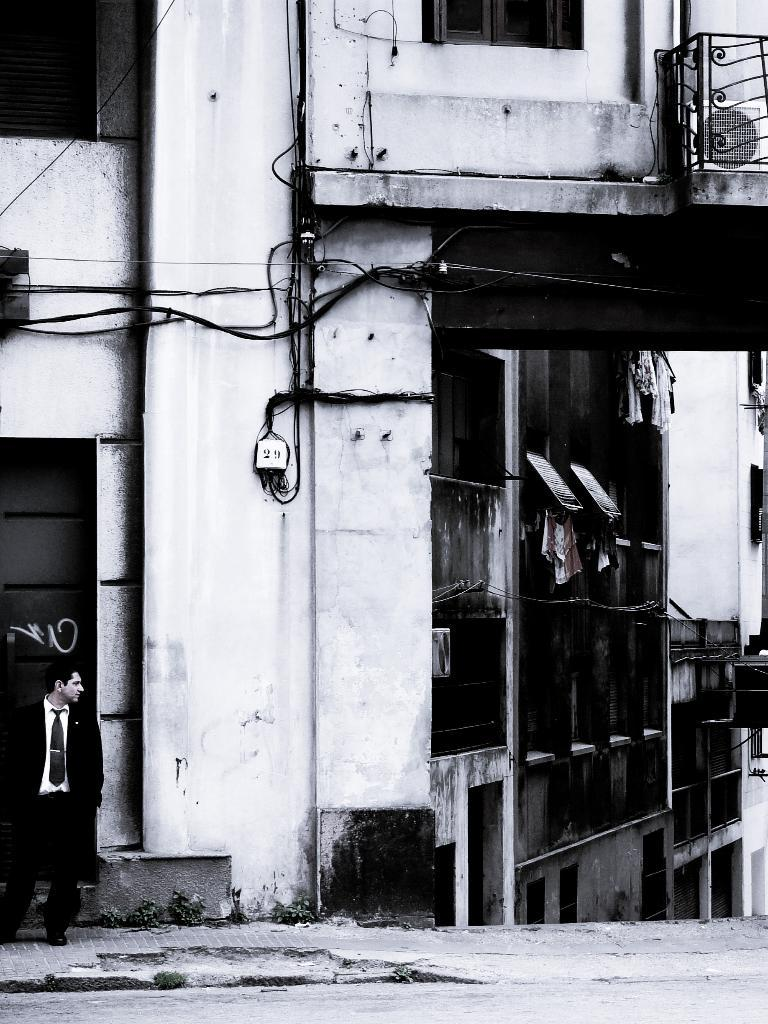What is happening in the foreground of the image? There is a person standing on the road in the foreground. What can be seen in the image besides the person on the road? There are windows, buildings, and wires visible in the image. What time of day was the image taken? The image was taken during the day. How many chickens are crossing the road in the image? There are no chickens present in the image. What type of wire is being used to act as a tightrope in the image? There is no wire being used as a tightrope in the image; only wires connecting utility poles are visible. 